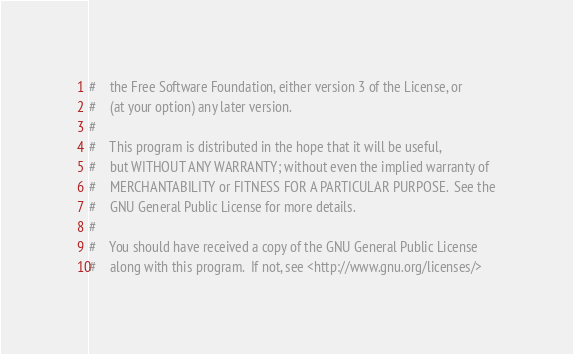<code> <loc_0><loc_0><loc_500><loc_500><_Python_>#    the Free Software Foundation, either version 3 of the License, or
#    (at your option) any later version.
#
#    This program is distributed in the hope that it will be useful,
#    but WITHOUT ANY WARRANTY; without even the implied warranty of
#    MERCHANTABILITY or FITNESS FOR A PARTICULAR PURPOSE.  See the
#    GNU General Public License for more details.
#
#    You should have received a copy of the GNU General Public License
#    along with this program.  If not, see <http://www.gnu.org/licenses/></code> 